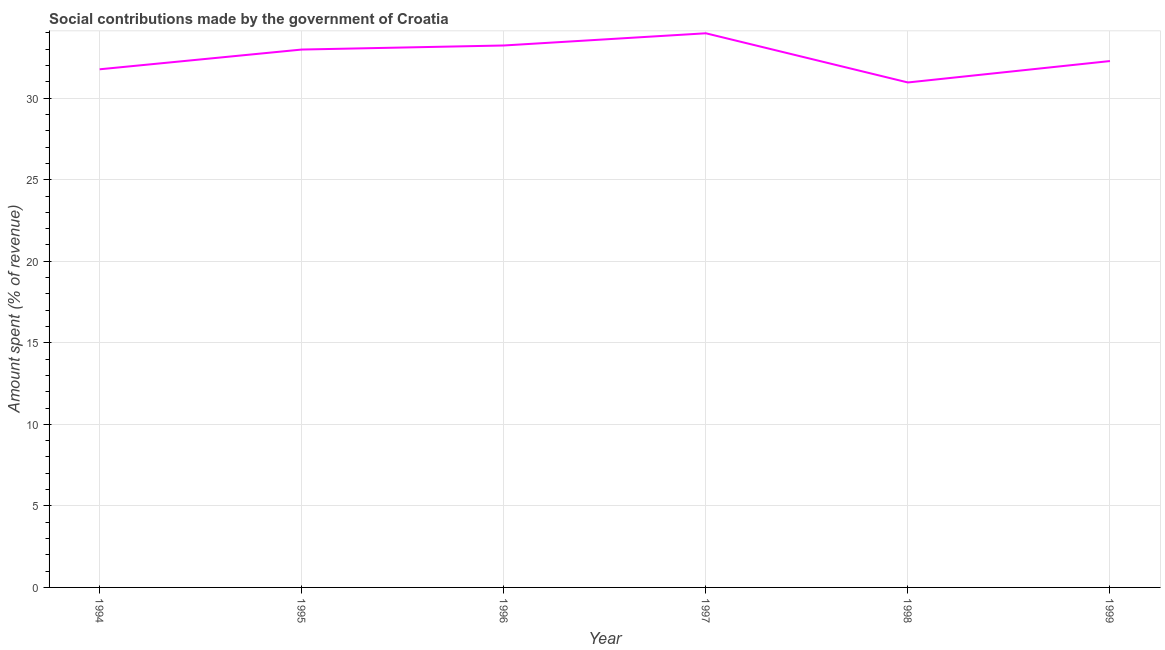What is the amount spent in making social contributions in 1996?
Your answer should be very brief. 33.23. Across all years, what is the maximum amount spent in making social contributions?
Ensure brevity in your answer.  33.98. Across all years, what is the minimum amount spent in making social contributions?
Your answer should be compact. 30.96. What is the sum of the amount spent in making social contributions?
Give a very brief answer. 195.19. What is the difference between the amount spent in making social contributions in 1995 and 1999?
Offer a terse response. 0.71. What is the average amount spent in making social contributions per year?
Make the answer very short. 32.53. What is the median amount spent in making social contributions?
Provide a short and direct response. 32.63. What is the ratio of the amount spent in making social contributions in 1994 to that in 1997?
Your answer should be very brief. 0.94. Is the difference between the amount spent in making social contributions in 1995 and 1997 greater than the difference between any two years?
Your answer should be very brief. No. What is the difference between the highest and the second highest amount spent in making social contributions?
Offer a terse response. 0.75. What is the difference between the highest and the lowest amount spent in making social contributions?
Keep it short and to the point. 3.02. In how many years, is the amount spent in making social contributions greater than the average amount spent in making social contributions taken over all years?
Offer a very short reply. 3. How many lines are there?
Provide a succinct answer. 1. What is the difference between two consecutive major ticks on the Y-axis?
Provide a succinct answer. 5. Are the values on the major ticks of Y-axis written in scientific E-notation?
Provide a succinct answer. No. Does the graph contain any zero values?
Your answer should be very brief. No. What is the title of the graph?
Make the answer very short. Social contributions made by the government of Croatia. What is the label or title of the Y-axis?
Give a very brief answer. Amount spent (% of revenue). What is the Amount spent (% of revenue) of 1994?
Make the answer very short. 31.77. What is the Amount spent (% of revenue) in 1995?
Offer a terse response. 32.98. What is the Amount spent (% of revenue) in 1996?
Offer a terse response. 33.23. What is the Amount spent (% of revenue) of 1997?
Give a very brief answer. 33.98. What is the Amount spent (% of revenue) in 1998?
Make the answer very short. 30.96. What is the Amount spent (% of revenue) in 1999?
Your response must be concise. 32.27. What is the difference between the Amount spent (% of revenue) in 1994 and 1995?
Your answer should be very brief. -1.21. What is the difference between the Amount spent (% of revenue) in 1994 and 1996?
Make the answer very short. -1.46. What is the difference between the Amount spent (% of revenue) in 1994 and 1997?
Provide a short and direct response. -2.21. What is the difference between the Amount spent (% of revenue) in 1994 and 1998?
Ensure brevity in your answer.  0.81. What is the difference between the Amount spent (% of revenue) in 1994 and 1999?
Your answer should be very brief. -0.5. What is the difference between the Amount spent (% of revenue) in 1995 and 1996?
Provide a short and direct response. -0.25. What is the difference between the Amount spent (% of revenue) in 1995 and 1997?
Provide a short and direct response. -1. What is the difference between the Amount spent (% of revenue) in 1995 and 1998?
Provide a short and direct response. 2.02. What is the difference between the Amount spent (% of revenue) in 1995 and 1999?
Provide a succinct answer. 0.71. What is the difference between the Amount spent (% of revenue) in 1996 and 1997?
Your response must be concise. -0.75. What is the difference between the Amount spent (% of revenue) in 1996 and 1998?
Keep it short and to the point. 2.27. What is the difference between the Amount spent (% of revenue) in 1996 and 1999?
Ensure brevity in your answer.  0.95. What is the difference between the Amount spent (% of revenue) in 1997 and 1998?
Make the answer very short. 3.02. What is the difference between the Amount spent (% of revenue) in 1997 and 1999?
Make the answer very short. 1.7. What is the difference between the Amount spent (% of revenue) in 1998 and 1999?
Your answer should be compact. -1.31. What is the ratio of the Amount spent (% of revenue) in 1994 to that in 1996?
Make the answer very short. 0.96. What is the ratio of the Amount spent (% of revenue) in 1994 to that in 1997?
Give a very brief answer. 0.94. What is the ratio of the Amount spent (% of revenue) in 1995 to that in 1998?
Give a very brief answer. 1.06. What is the ratio of the Amount spent (% of revenue) in 1995 to that in 1999?
Offer a terse response. 1.02. What is the ratio of the Amount spent (% of revenue) in 1996 to that in 1997?
Offer a terse response. 0.98. What is the ratio of the Amount spent (% of revenue) in 1996 to that in 1998?
Provide a short and direct response. 1.07. What is the ratio of the Amount spent (% of revenue) in 1997 to that in 1998?
Provide a succinct answer. 1.1. What is the ratio of the Amount spent (% of revenue) in 1997 to that in 1999?
Your response must be concise. 1.05. What is the ratio of the Amount spent (% of revenue) in 1998 to that in 1999?
Offer a very short reply. 0.96. 